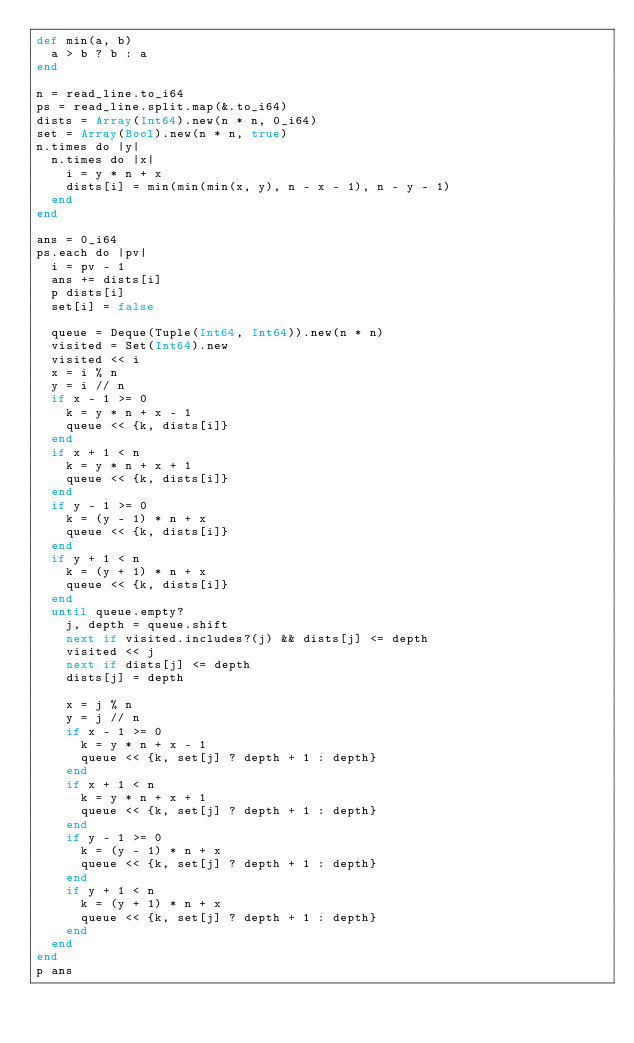<code> <loc_0><loc_0><loc_500><loc_500><_Crystal_>def min(a, b)
  a > b ? b : a
end

n = read_line.to_i64
ps = read_line.split.map(&.to_i64)
dists = Array(Int64).new(n * n, 0_i64)
set = Array(Bool).new(n * n, true)
n.times do |y|
  n.times do |x|
    i = y * n + x
    dists[i] = min(min(min(x, y), n - x - 1), n - y - 1)
  end
end

ans = 0_i64
ps.each do |pv|
  i = pv - 1
  ans += dists[i]
  p dists[i]
  set[i] = false

  queue = Deque(Tuple(Int64, Int64)).new(n * n)
  visited = Set(Int64).new
  visited << i
  x = i % n
  y = i // n
  if x - 1 >= 0
    k = y * n + x - 1
    queue << {k, dists[i]}
  end
  if x + 1 < n
    k = y * n + x + 1
    queue << {k, dists[i]}
  end
  if y - 1 >= 0
    k = (y - 1) * n + x
    queue << {k, dists[i]}
  end
  if y + 1 < n
    k = (y + 1) * n + x
    queue << {k, dists[i]}
  end
  until queue.empty?
    j, depth = queue.shift
    next if visited.includes?(j) && dists[j] <= depth
    visited << j
    next if dists[j] <= depth
    dists[j] = depth

    x = j % n
    y = j // n
    if x - 1 >= 0
      k = y * n + x - 1
      queue << {k, set[j] ? depth + 1 : depth}
    end
    if x + 1 < n
      k = y * n + x + 1
      queue << {k, set[j] ? depth + 1 : depth}
    end
    if y - 1 >= 0
      k = (y - 1) * n + x
      queue << {k, set[j] ? depth + 1 : depth}
    end
    if y + 1 < n
      k = (y + 1) * n + x
      queue << {k, set[j] ? depth + 1 : depth}
    end
  end
end
p ans
</code> 